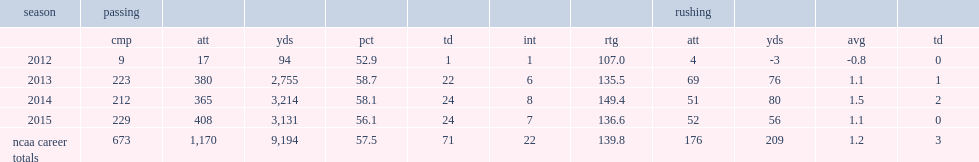How many passing yards did cook get in 2013? 2755.0. 